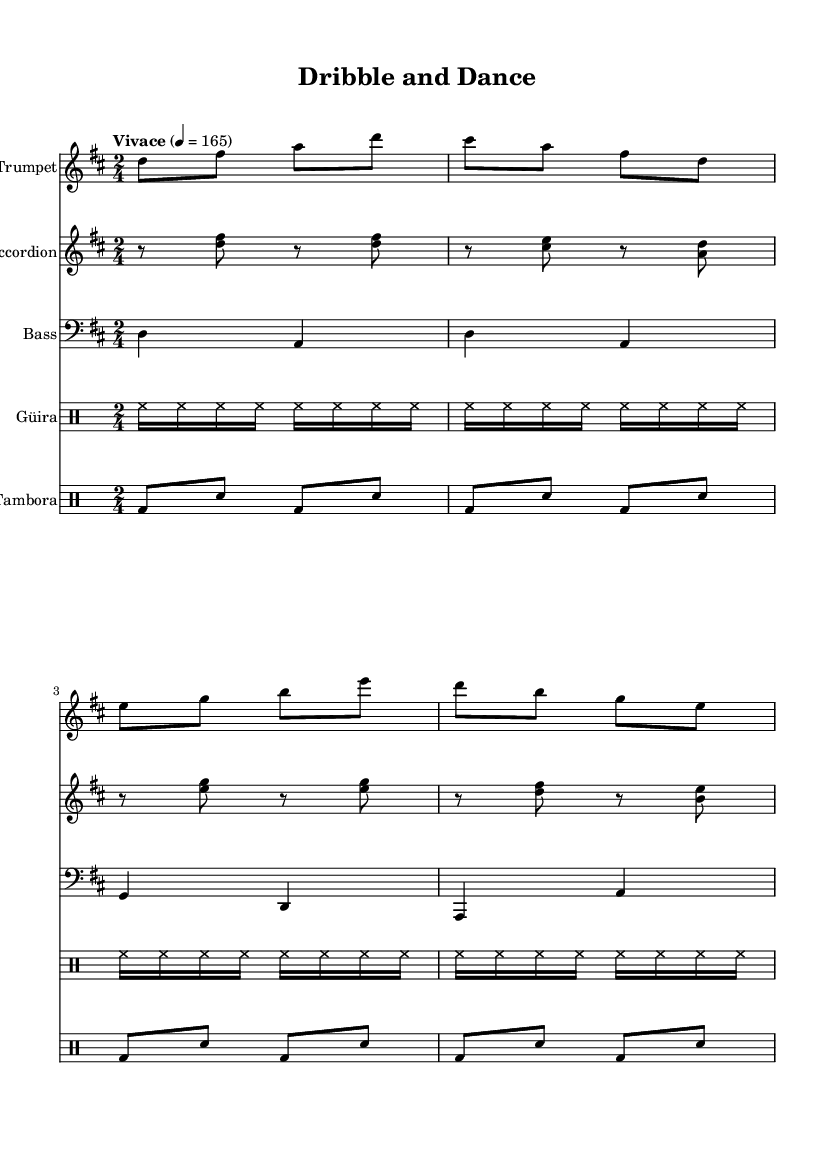What is the key signature of this music? The key signature is indicated at the beginning of the staff and shows two sharps, which corresponds to D major.
Answer: D major What is the time signature of this piece? The time signature is found at the beginning of the score and is indicated as 2/4, meaning there are two beats per measure and the quarter note gets one beat.
Answer: 2/4 What is the tempo marking of the music? The tempo is noted at the start and is labeled as "Vivace," which translates to a lively and fast tempo. Additionally, the numerical marking shows 4 equals 165, specifying the beats per minute.
Answer: Vivace Which instrument plays the bass line? The bass line is indicated by the clef used in the staff; it is written in the bass clef, which is standard for bass instruments. The label for the staff clearly states "Bass."
Answer: Bass How often does the güira play in a measure? The güira pattern is crafted in sixteenth notes and repeats four times, indicating that it plays continuously throughout the measure within the defined rhythmic structure.
Answer: Eight times What is the rhythmic pattern of the tambora part? The tambora part consists of alternating bass drum and snare hits organized in a consistent 8-beat sequence, creating a well-defined rhythmic pattern in each measure.
Answer: Alternate bass and snare What section of the song is mainly for dancing and cardio workouts? The overall character of the piece is indicated by the "Vivace" tempo and rhythmic patterns alongside a lively instrumentation, making it suitable for both dancing and cardio workouts.
Answer: Whole piece 